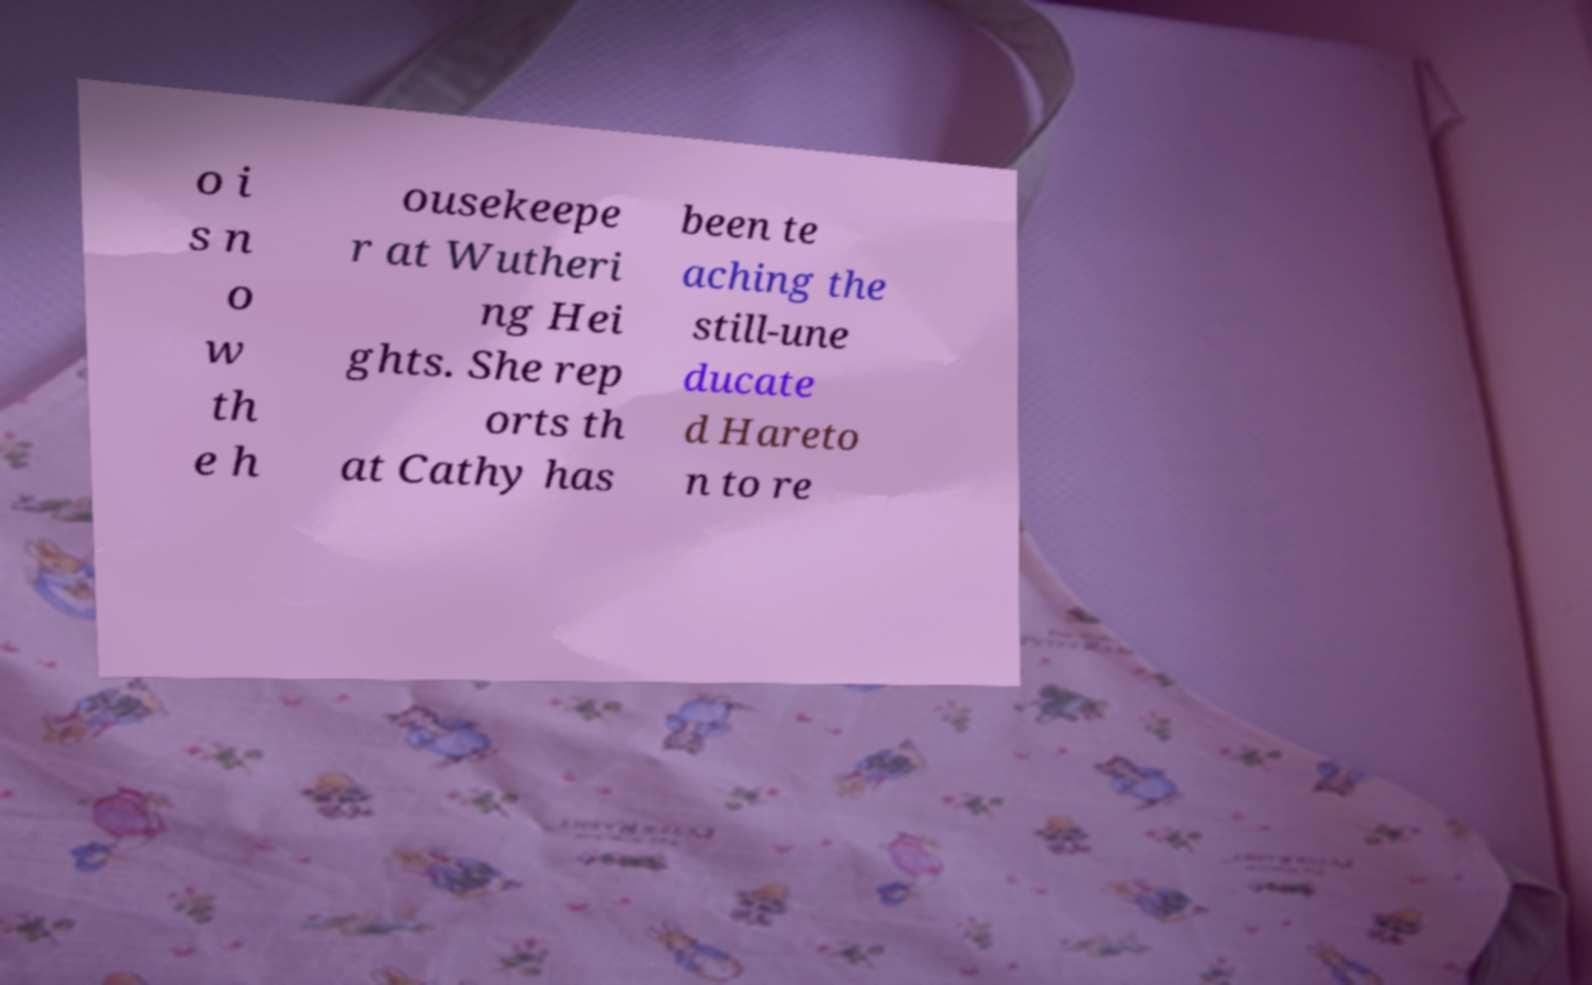Can you accurately transcribe the text from the provided image for me? o i s n o w th e h ousekeepe r at Wutheri ng Hei ghts. She rep orts th at Cathy has been te aching the still-une ducate d Hareto n to re 